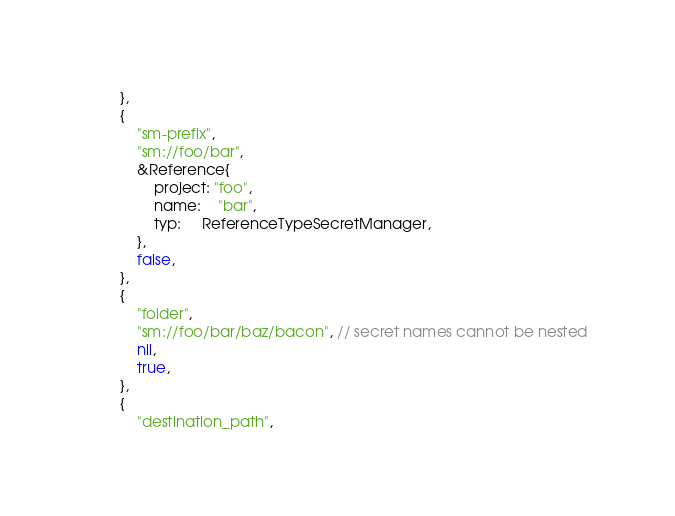<code> <loc_0><loc_0><loc_500><loc_500><_Go_>		},
		{
			"sm-prefix",
			"sm://foo/bar",
			&Reference{
				project: "foo",
				name:    "bar",
				typ:     ReferenceTypeSecretManager,
			},
			false,
		},
		{
			"folder",
			"sm://foo/bar/baz/bacon", // secret names cannot be nested
			nil,
			true,
		},
		{
			"destination_path",</code> 